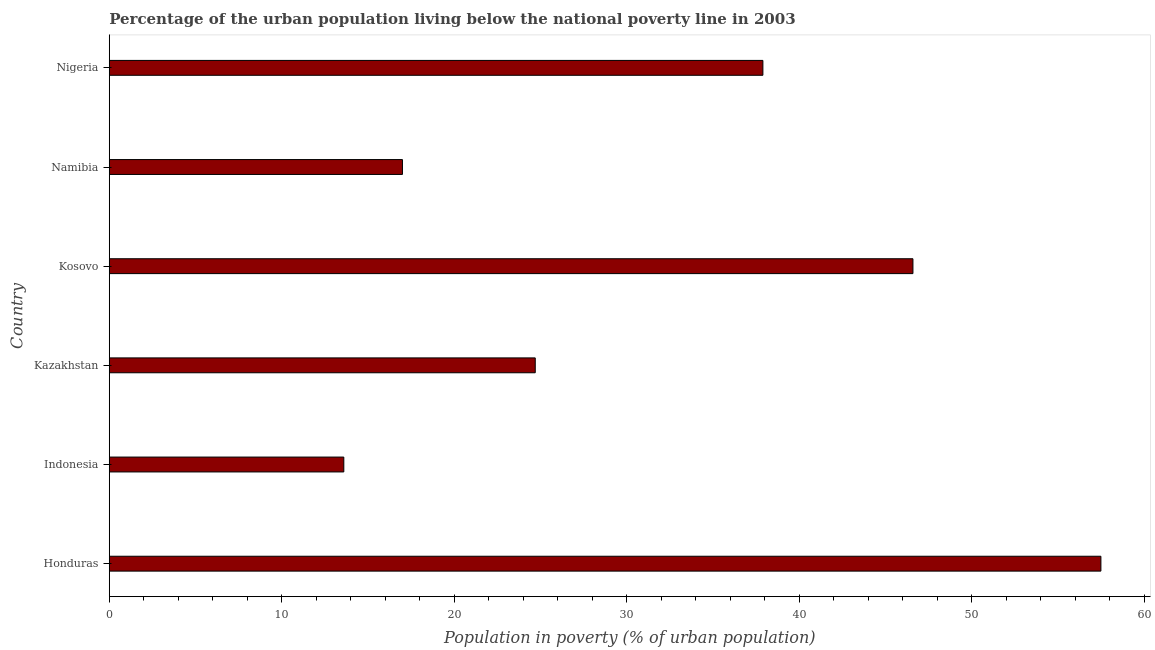Does the graph contain grids?
Provide a short and direct response. No. What is the title of the graph?
Offer a terse response. Percentage of the urban population living below the national poverty line in 2003. What is the label or title of the X-axis?
Ensure brevity in your answer.  Population in poverty (% of urban population). What is the percentage of urban population living below poverty line in Honduras?
Your answer should be compact. 57.5. Across all countries, what is the maximum percentage of urban population living below poverty line?
Your response must be concise. 57.5. In which country was the percentage of urban population living below poverty line maximum?
Offer a very short reply. Honduras. What is the sum of the percentage of urban population living below poverty line?
Offer a terse response. 197.3. What is the difference between the percentage of urban population living below poverty line in Honduras and Kazakhstan?
Your answer should be very brief. 32.8. What is the average percentage of urban population living below poverty line per country?
Your answer should be compact. 32.88. What is the median percentage of urban population living below poverty line?
Give a very brief answer. 31.3. In how many countries, is the percentage of urban population living below poverty line greater than 24 %?
Your response must be concise. 4. What is the ratio of the percentage of urban population living below poverty line in Honduras to that in Namibia?
Offer a very short reply. 3.38. Is the difference between the percentage of urban population living below poverty line in Namibia and Nigeria greater than the difference between any two countries?
Offer a very short reply. No. What is the difference between the highest and the second highest percentage of urban population living below poverty line?
Your answer should be very brief. 10.9. What is the difference between the highest and the lowest percentage of urban population living below poverty line?
Your answer should be very brief. 43.9. In how many countries, is the percentage of urban population living below poverty line greater than the average percentage of urban population living below poverty line taken over all countries?
Give a very brief answer. 3. How many countries are there in the graph?
Offer a very short reply. 6. What is the difference between two consecutive major ticks on the X-axis?
Give a very brief answer. 10. Are the values on the major ticks of X-axis written in scientific E-notation?
Provide a succinct answer. No. What is the Population in poverty (% of urban population) of Honduras?
Provide a succinct answer. 57.5. What is the Population in poverty (% of urban population) in Kazakhstan?
Make the answer very short. 24.7. What is the Population in poverty (% of urban population) of Kosovo?
Offer a terse response. 46.6. What is the Population in poverty (% of urban population) in Nigeria?
Your response must be concise. 37.9. What is the difference between the Population in poverty (% of urban population) in Honduras and Indonesia?
Make the answer very short. 43.9. What is the difference between the Population in poverty (% of urban population) in Honduras and Kazakhstan?
Make the answer very short. 32.8. What is the difference between the Population in poverty (% of urban population) in Honduras and Kosovo?
Keep it short and to the point. 10.9. What is the difference between the Population in poverty (% of urban population) in Honduras and Namibia?
Your response must be concise. 40.5. What is the difference between the Population in poverty (% of urban population) in Honduras and Nigeria?
Make the answer very short. 19.6. What is the difference between the Population in poverty (% of urban population) in Indonesia and Kazakhstan?
Offer a very short reply. -11.1. What is the difference between the Population in poverty (% of urban population) in Indonesia and Kosovo?
Offer a terse response. -33. What is the difference between the Population in poverty (% of urban population) in Indonesia and Nigeria?
Make the answer very short. -24.3. What is the difference between the Population in poverty (% of urban population) in Kazakhstan and Kosovo?
Keep it short and to the point. -21.9. What is the difference between the Population in poverty (% of urban population) in Kosovo and Namibia?
Provide a succinct answer. 29.6. What is the difference between the Population in poverty (% of urban population) in Namibia and Nigeria?
Keep it short and to the point. -20.9. What is the ratio of the Population in poverty (% of urban population) in Honduras to that in Indonesia?
Offer a very short reply. 4.23. What is the ratio of the Population in poverty (% of urban population) in Honduras to that in Kazakhstan?
Offer a terse response. 2.33. What is the ratio of the Population in poverty (% of urban population) in Honduras to that in Kosovo?
Your answer should be very brief. 1.23. What is the ratio of the Population in poverty (% of urban population) in Honduras to that in Namibia?
Ensure brevity in your answer.  3.38. What is the ratio of the Population in poverty (% of urban population) in Honduras to that in Nigeria?
Your response must be concise. 1.52. What is the ratio of the Population in poverty (% of urban population) in Indonesia to that in Kazakhstan?
Your answer should be compact. 0.55. What is the ratio of the Population in poverty (% of urban population) in Indonesia to that in Kosovo?
Make the answer very short. 0.29. What is the ratio of the Population in poverty (% of urban population) in Indonesia to that in Nigeria?
Provide a succinct answer. 0.36. What is the ratio of the Population in poverty (% of urban population) in Kazakhstan to that in Kosovo?
Your answer should be very brief. 0.53. What is the ratio of the Population in poverty (% of urban population) in Kazakhstan to that in Namibia?
Your answer should be very brief. 1.45. What is the ratio of the Population in poverty (% of urban population) in Kazakhstan to that in Nigeria?
Ensure brevity in your answer.  0.65. What is the ratio of the Population in poverty (% of urban population) in Kosovo to that in Namibia?
Give a very brief answer. 2.74. What is the ratio of the Population in poverty (% of urban population) in Kosovo to that in Nigeria?
Keep it short and to the point. 1.23. What is the ratio of the Population in poverty (% of urban population) in Namibia to that in Nigeria?
Ensure brevity in your answer.  0.45. 